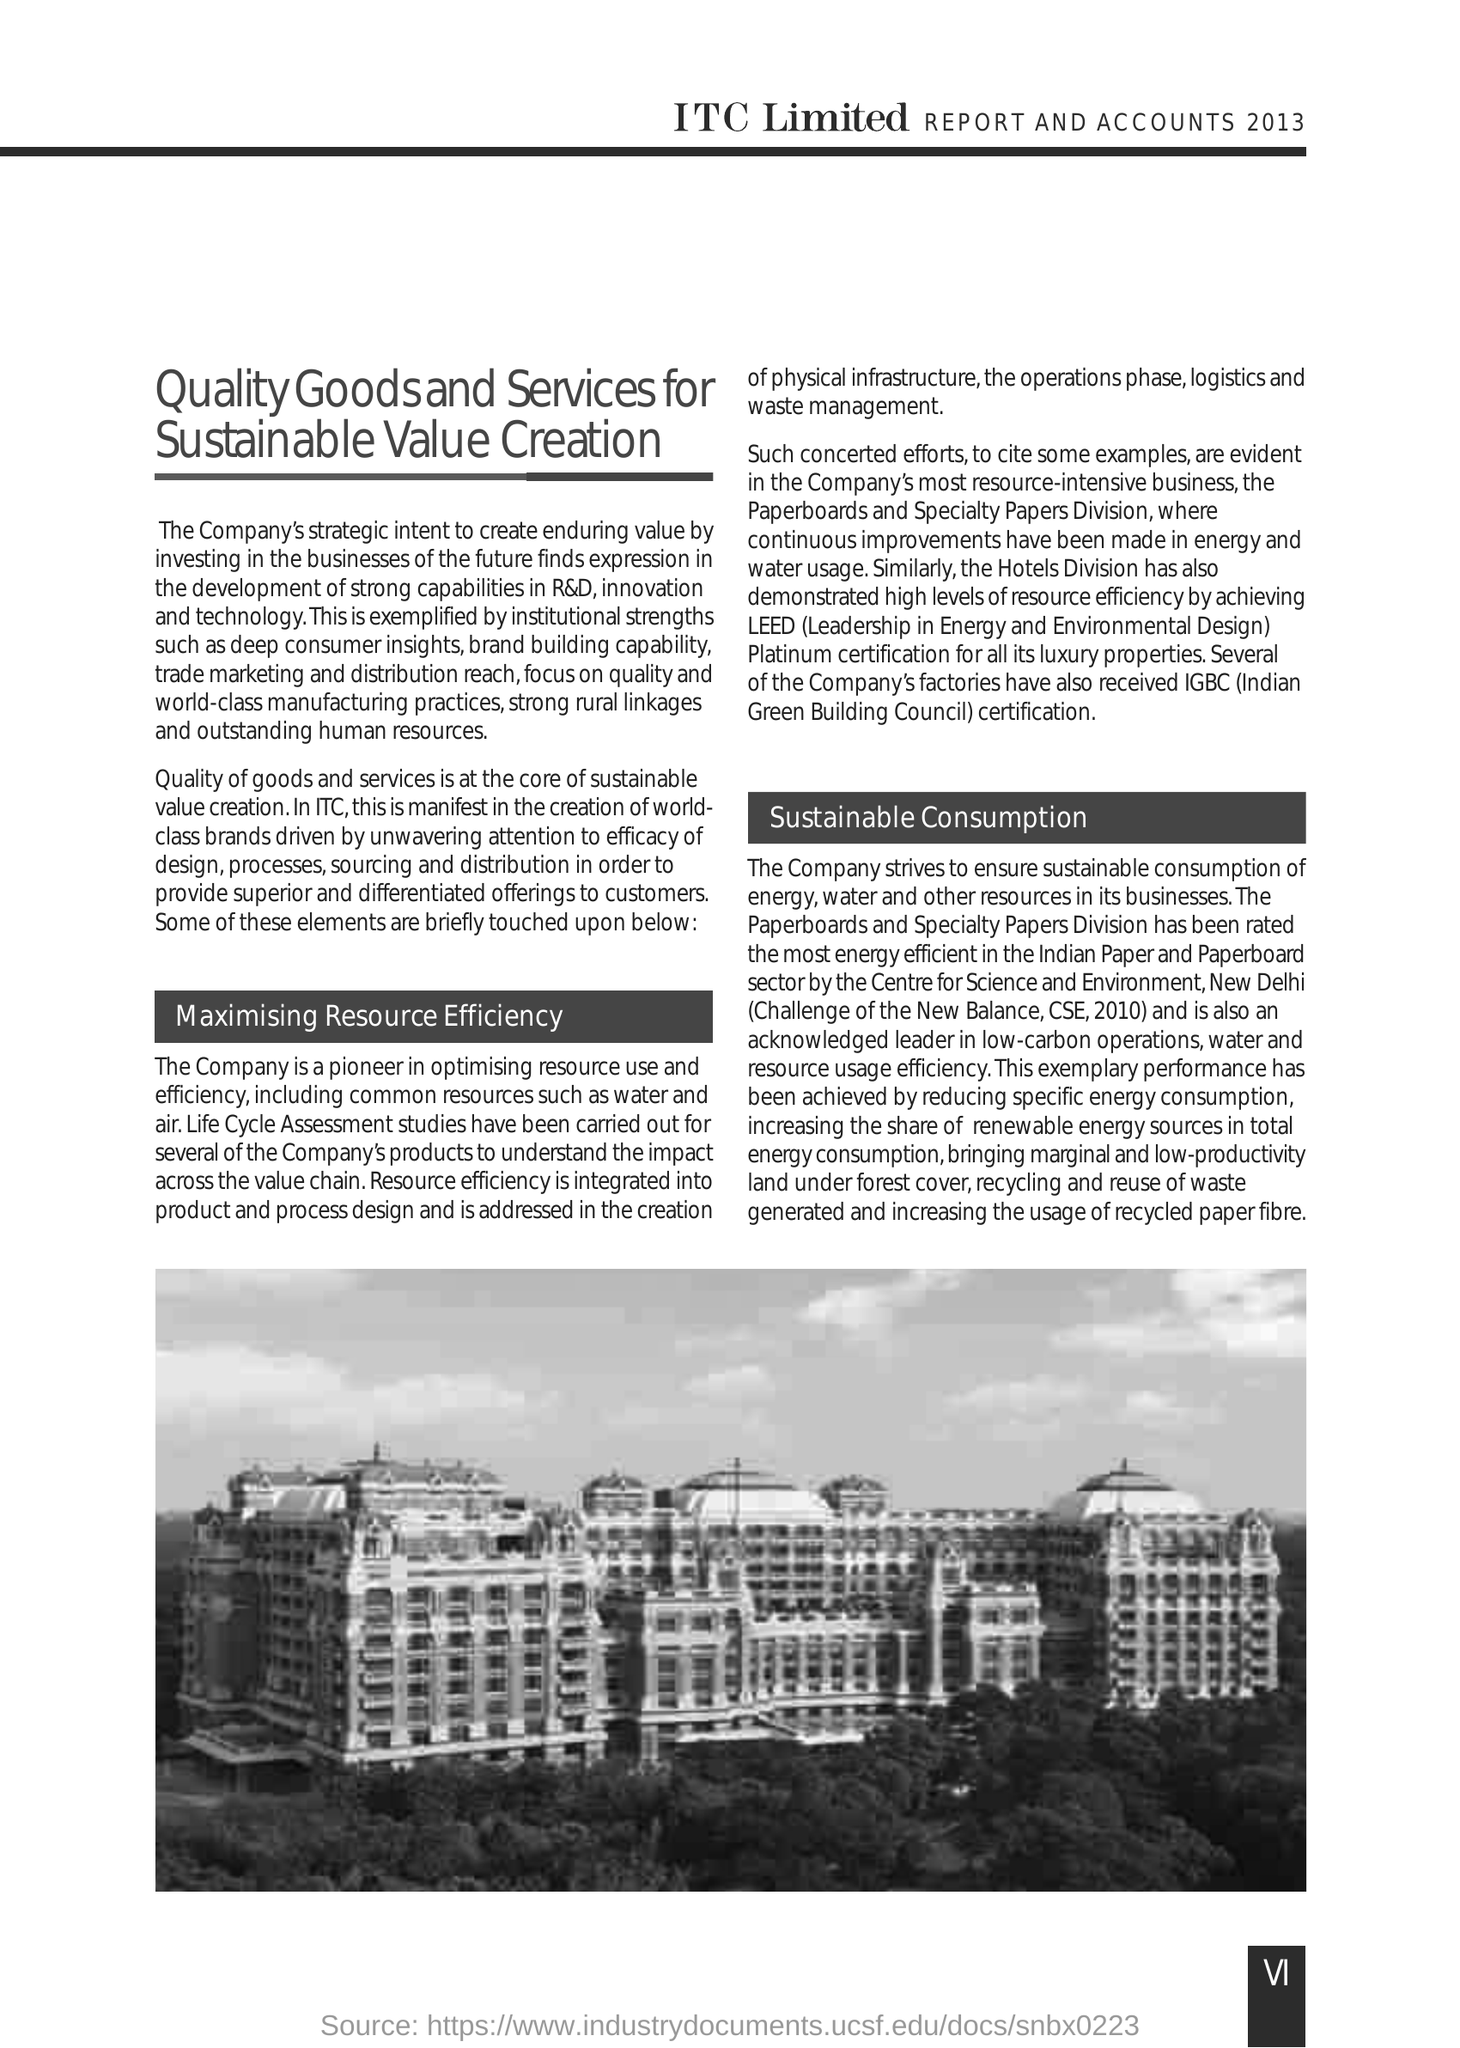Highlight a few significant elements in this photo. The full form of CSE is Centre for Science and Environment, which is an organization dedicated to promoting scientific research and environmental awareness. The full form of IGBC is Indian Green Building Council. 